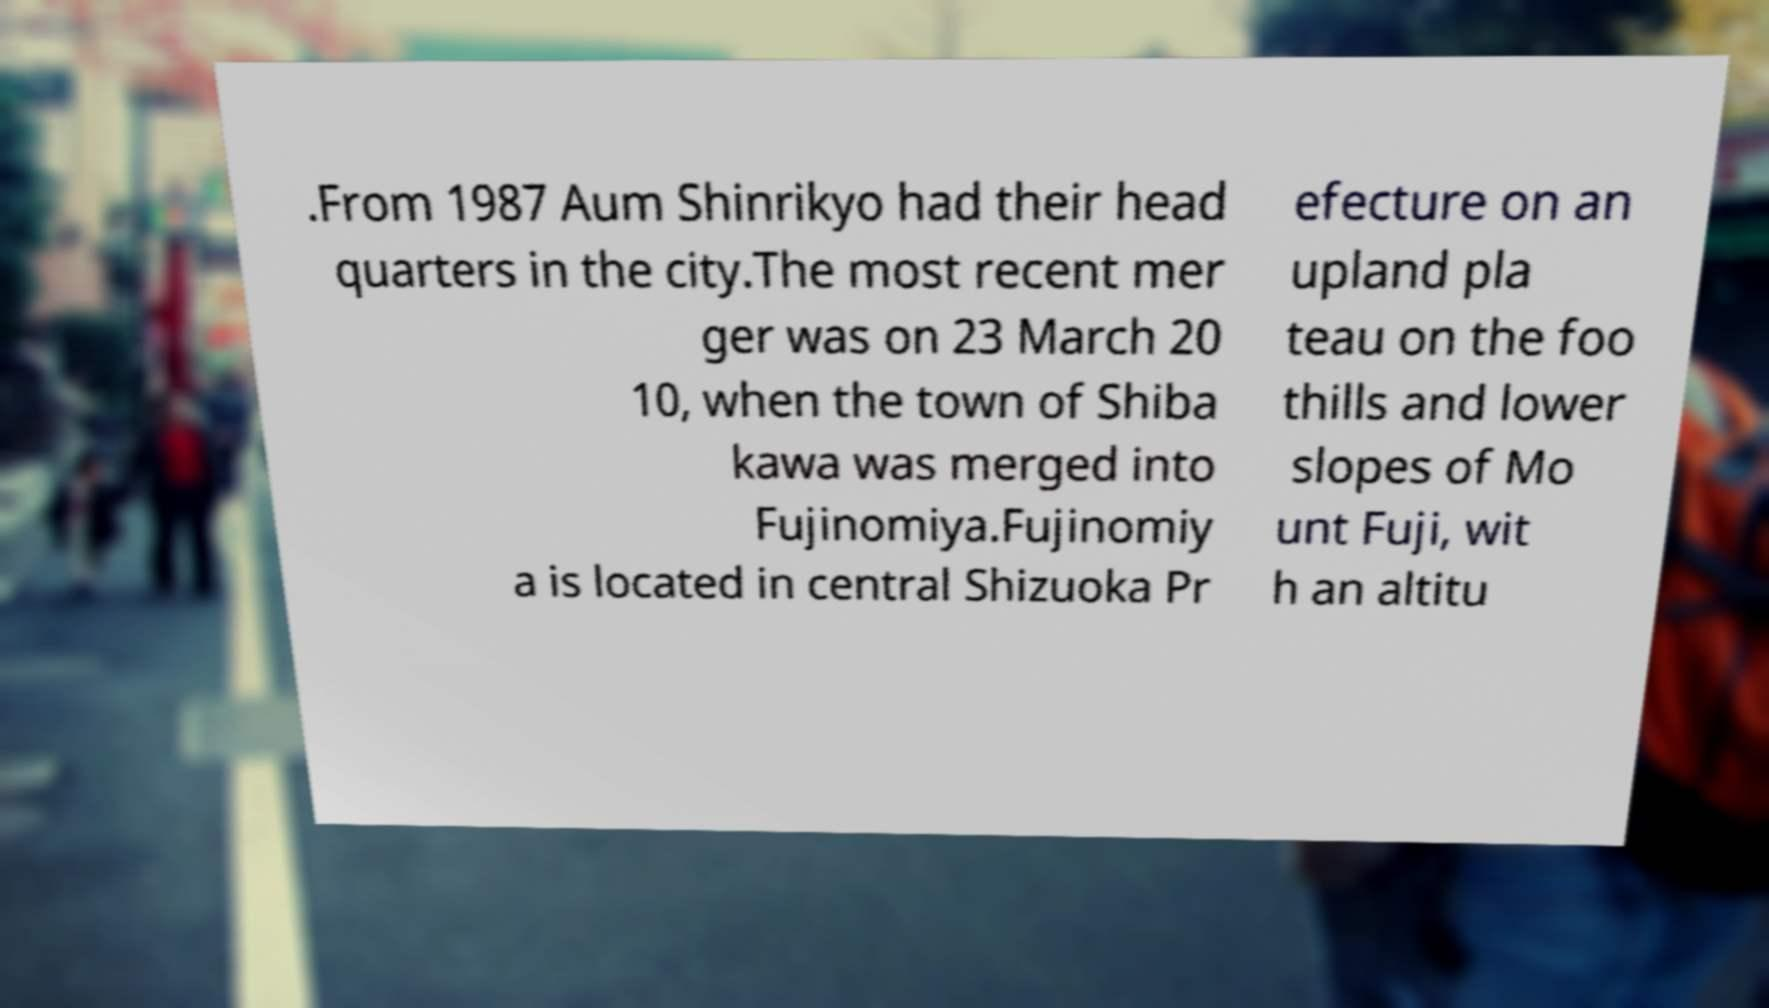Please identify and transcribe the text found in this image. .From 1987 Aum Shinrikyo had their head quarters in the city.The most recent mer ger was on 23 March 20 10, when the town of Shiba kawa was merged into Fujinomiya.Fujinomiy a is located in central Shizuoka Pr efecture on an upland pla teau on the foo thills and lower slopes of Mo unt Fuji, wit h an altitu 